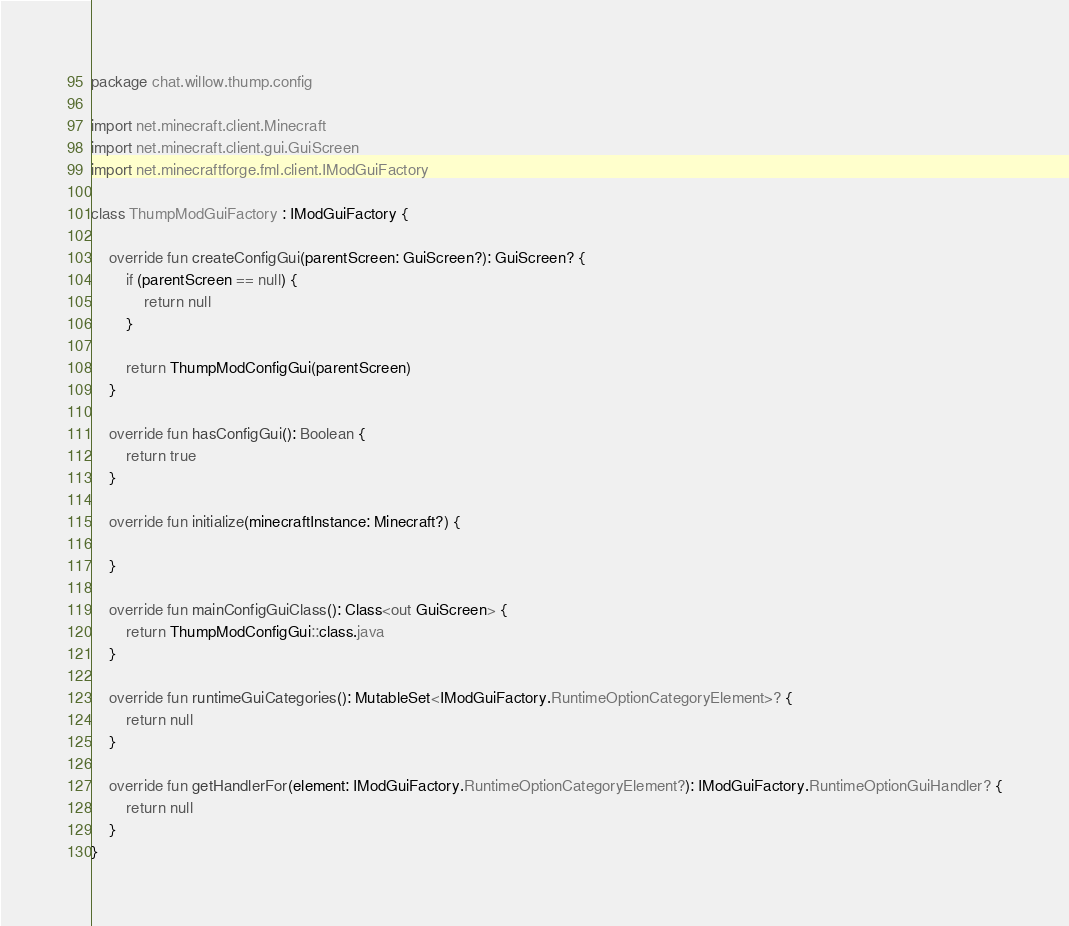Convert code to text. <code><loc_0><loc_0><loc_500><loc_500><_Kotlin_>package chat.willow.thump.config

import net.minecraft.client.Minecraft
import net.minecraft.client.gui.GuiScreen
import net.minecraftforge.fml.client.IModGuiFactory

class ThumpModGuiFactory : IModGuiFactory {

    override fun createConfigGui(parentScreen: GuiScreen?): GuiScreen? {
        if (parentScreen == null) {
            return null
        }

        return ThumpModConfigGui(parentScreen)
    }

    override fun hasConfigGui(): Boolean {
        return true
    }

    override fun initialize(minecraftInstance: Minecraft?) {

    }

    override fun mainConfigGuiClass(): Class<out GuiScreen> {
        return ThumpModConfigGui::class.java
    }

    override fun runtimeGuiCategories(): MutableSet<IModGuiFactory.RuntimeOptionCategoryElement>? {
        return null
    }

    override fun getHandlerFor(element: IModGuiFactory.RuntimeOptionCategoryElement?): IModGuiFactory.RuntimeOptionGuiHandler? {
        return null
    }
}</code> 